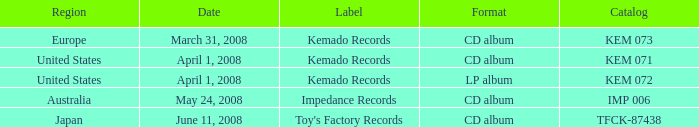Would you mind parsing the complete table? {'header': ['Region', 'Date', 'Label', 'Format', 'Catalog'], 'rows': [['Europe', 'March 31, 2008', 'Kemado Records', 'CD album', 'KEM 073'], ['United States', 'April 1, 2008', 'Kemado Records', 'CD album', 'KEM 071'], ['United States', 'April 1, 2008', 'Kemado Records', 'LP album', 'KEM 072'], ['Australia', 'May 24, 2008', 'Impedance Records', 'CD album', 'IMP 006'], ['Japan', 'June 11, 2008', "Toy's Factory Records", 'CD album', 'TFCK-87438']]} Which Region has a Format of cd album, and a Label of kemado records, and a Catalog of kem 071? United States. 